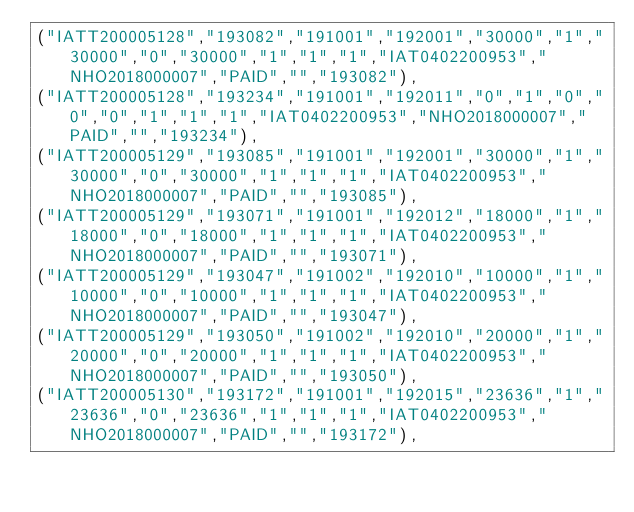<code> <loc_0><loc_0><loc_500><loc_500><_SQL_>("IATT200005128","193082","191001","192001","30000","1","30000","0","30000","1","1","1","IAT0402200953","NHO2018000007","PAID","","193082"),
("IATT200005128","193234","191001","192011","0","1","0","0","0","1","1","1","IAT0402200953","NHO2018000007","PAID","","193234"),
("IATT200005129","193085","191001","192001","30000","1","30000","0","30000","1","1","1","IAT0402200953","NHO2018000007","PAID","","193085"),
("IATT200005129","193071","191001","192012","18000","1","18000","0","18000","1","1","1","IAT0402200953","NHO2018000007","PAID","","193071"),
("IATT200005129","193047","191002","192010","10000","1","10000","0","10000","1","1","1","IAT0402200953","NHO2018000007","PAID","","193047"),
("IATT200005129","193050","191002","192010","20000","1","20000","0","20000","1","1","1","IAT0402200953","NHO2018000007","PAID","","193050"),
("IATT200005130","193172","191001","192015","23636","1","23636","0","23636","1","1","1","IAT0402200953","NHO2018000007","PAID","","193172"),</code> 